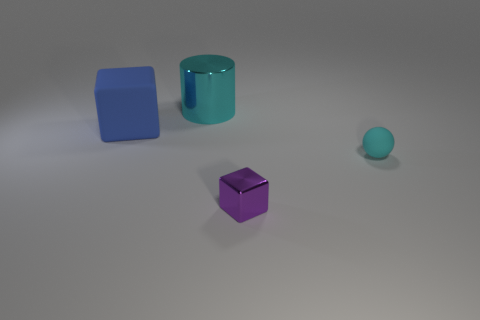What is the material of the cube behind the cyan thing in front of the block behind the small cyan object? While I cannot verify the exact material of objects in an image, the cube that you're referring to appears matte and exhibits light diffusing properties. These are commonly characteristics of rubber or plastic. However, since the entire scene might be computer-generated, it could also simply be textured to mimic such a material. 